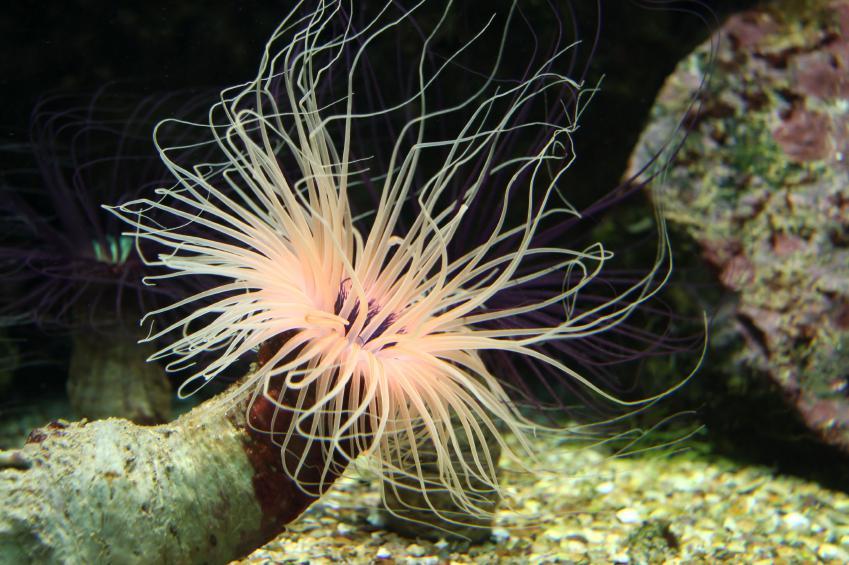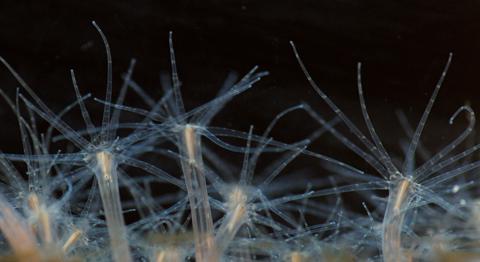The first image is the image on the left, the second image is the image on the right. Given the left and right images, does the statement "Each image shows only a single living organism." hold true? Answer yes or no. No. The first image is the image on the left, the second image is the image on the right. Evaluate the accuracy of this statement regarding the images: "An image shows at least one anemone with tapering tendrils that has its stalk on a rock-like surface.". Is it true? Answer yes or no. Yes. 